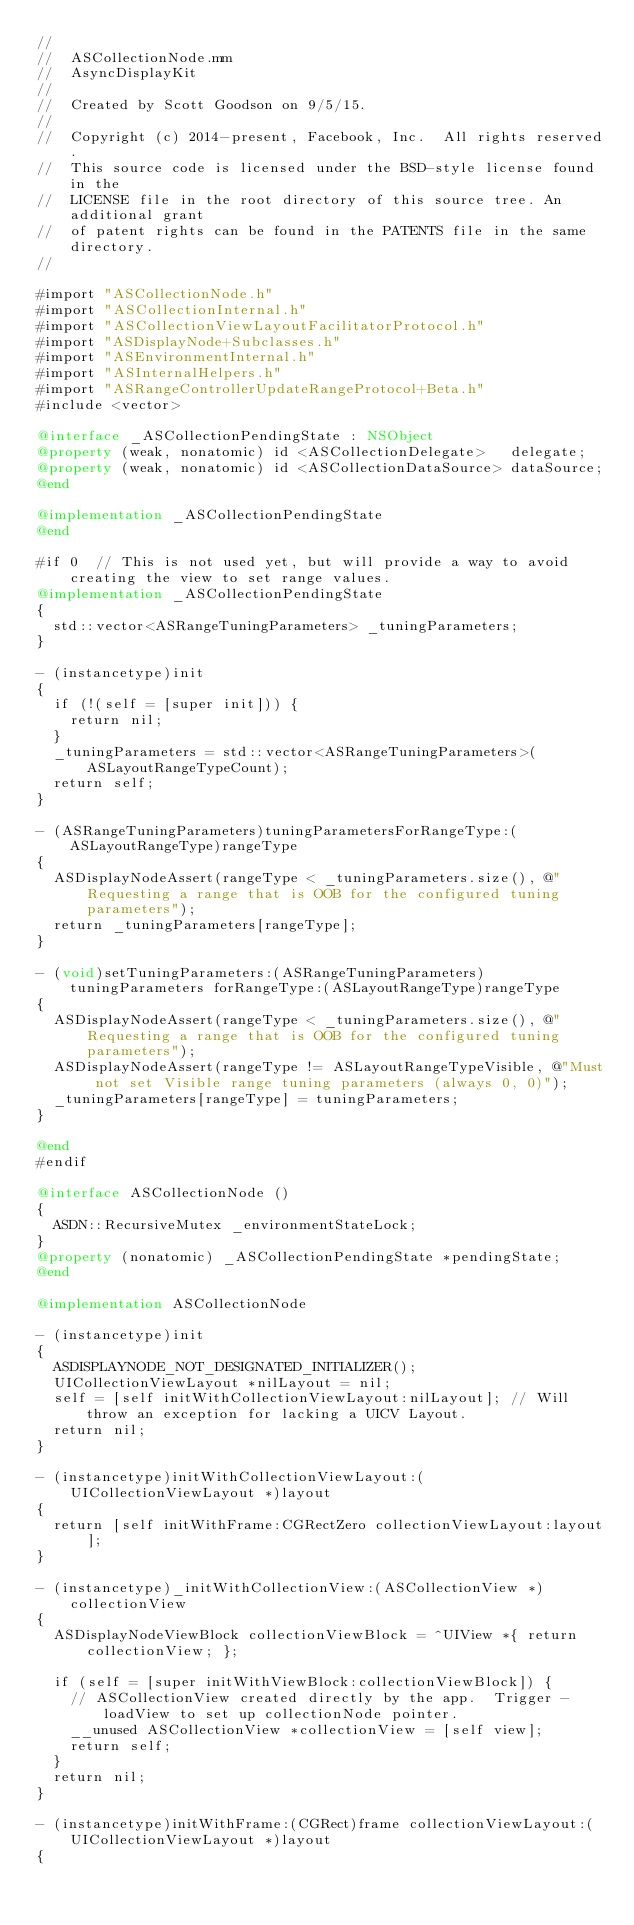<code> <loc_0><loc_0><loc_500><loc_500><_ObjectiveC_>//
//  ASCollectionNode.mm
//  AsyncDisplayKit
//
//  Created by Scott Goodson on 9/5/15.
//
//  Copyright (c) 2014-present, Facebook, Inc.  All rights reserved.
//  This source code is licensed under the BSD-style license found in the
//  LICENSE file in the root directory of this source tree. An additional grant
//  of patent rights can be found in the PATENTS file in the same directory.
//

#import "ASCollectionNode.h"
#import "ASCollectionInternal.h"
#import "ASCollectionViewLayoutFacilitatorProtocol.h"
#import "ASDisplayNode+Subclasses.h"
#import "ASEnvironmentInternal.h"
#import "ASInternalHelpers.h"
#import "ASRangeControllerUpdateRangeProtocol+Beta.h"
#include <vector>

@interface _ASCollectionPendingState : NSObject
@property (weak, nonatomic) id <ASCollectionDelegate>   delegate;
@property (weak, nonatomic) id <ASCollectionDataSource> dataSource;
@end

@implementation _ASCollectionPendingState
@end

#if 0  // This is not used yet, but will provide a way to avoid creating the view to set range values.
@implementation _ASCollectionPendingState
{
  std::vector<ASRangeTuningParameters> _tuningParameters;
}

- (instancetype)init
{
  if (!(self = [super init])) {
    return nil;
  }
  _tuningParameters = std::vector<ASRangeTuningParameters>(ASLayoutRangeTypeCount);
  return self;
}

- (ASRangeTuningParameters)tuningParametersForRangeType:(ASLayoutRangeType)rangeType
{
  ASDisplayNodeAssert(rangeType < _tuningParameters.size(), @"Requesting a range that is OOB for the configured tuning parameters");
  return _tuningParameters[rangeType];
}

- (void)setTuningParameters:(ASRangeTuningParameters)tuningParameters forRangeType:(ASLayoutRangeType)rangeType
{
  ASDisplayNodeAssert(rangeType < _tuningParameters.size(), @"Requesting a range that is OOB for the configured tuning parameters");
  ASDisplayNodeAssert(rangeType != ASLayoutRangeTypeVisible, @"Must not set Visible range tuning parameters (always 0, 0)");
  _tuningParameters[rangeType] = tuningParameters;
}

@end
#endif

@interface ASCollectionNode ()
{
  ASDN::RecursiveMutex _environmentStateLock;
}
@property (nonatomic) _ASCollectionPendingState *pendingState;
@end

@implementation ASCollectionNode

- (instancetype)init
{
  ASDISPLAYNODE_NOT_DESIGNATED_INITIALIZER();
  UICollectionViewLayout *nilLayout = nil;
  self = [self initWithCollectionViewLayout:nilLayout]; // Will throw an exception for lacking a UICV Layout.
  return nil;
}

- (instancetype)initWithCollectionViewLayout:(UICollectionViewLayout *)layout
{
  return [self initWithFrame:CGRectZero collectionViewLayout:layout];
}

- (instancetype)_initWithCollectionView:(ASCollectionView *)collectionView
{
  ASDisplayNodeViewBlock collectionViewBlock = ^UIView *{ return collectionView; };
  
  if (self = [super initWithViewBlock:collectionViewBlock]) {
    // ASCollectionView created directly by the app.  Trigger -loadView to set up collectionNode pointer.
    __unused ASCollectionView *collectionView = [self view];
    return self;
  }
  return nil;
}

- (instancetype)initWithFrame:(CGRect)frame collectionViewLayout:(UICollectionViewLayout *)layout
{</code> 